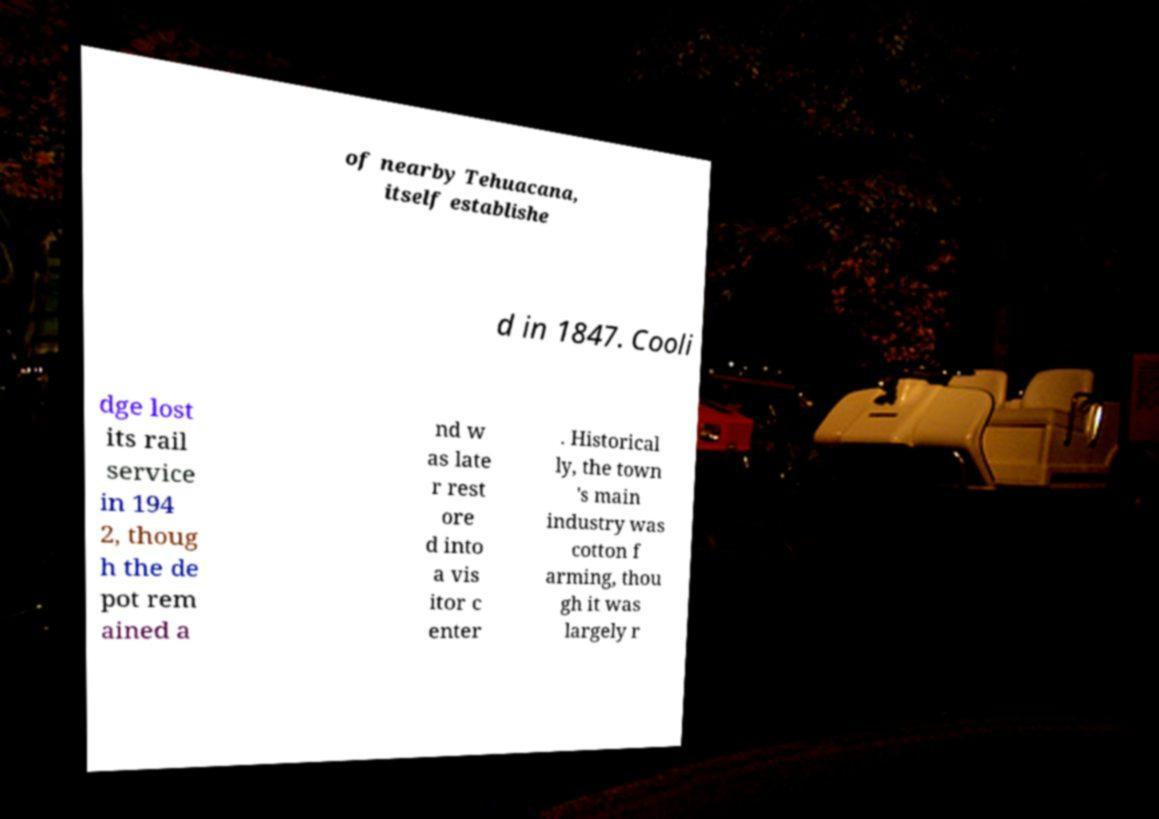For documentation purposes, I need the text within this image transcribed. Could you provide that? of nearby Tehuacana, itself establishe d in 1847. Cooli dge lost its rail service in 194 2, thoug h the de pot rem ained a nd w as late r rest ore d into a vis itor c enter . Historical ly, the town 's main industry was cotton f arming, thou gh it was largely r 